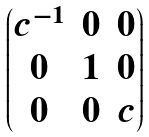Convert formula to latex. <formula><loc_0><loc_0><loc_500><loc_500>\begin{pmatrix} c ^ { - 1 } & 0 & 0 \\ 0 & 1 & 0 \\ 0 & 0 & c \end{pmatrix}</formula> 